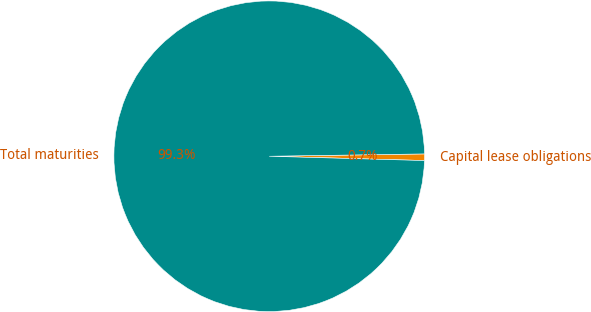Convert chart to OTSL. <chart><loc_0><loc_0><loc_500><loc_500><pie_chart><fcel>Capital lease obligations<fcel>Total maturities<nl><fcel>0.68%<fcel>99.32%<nl></chart> 